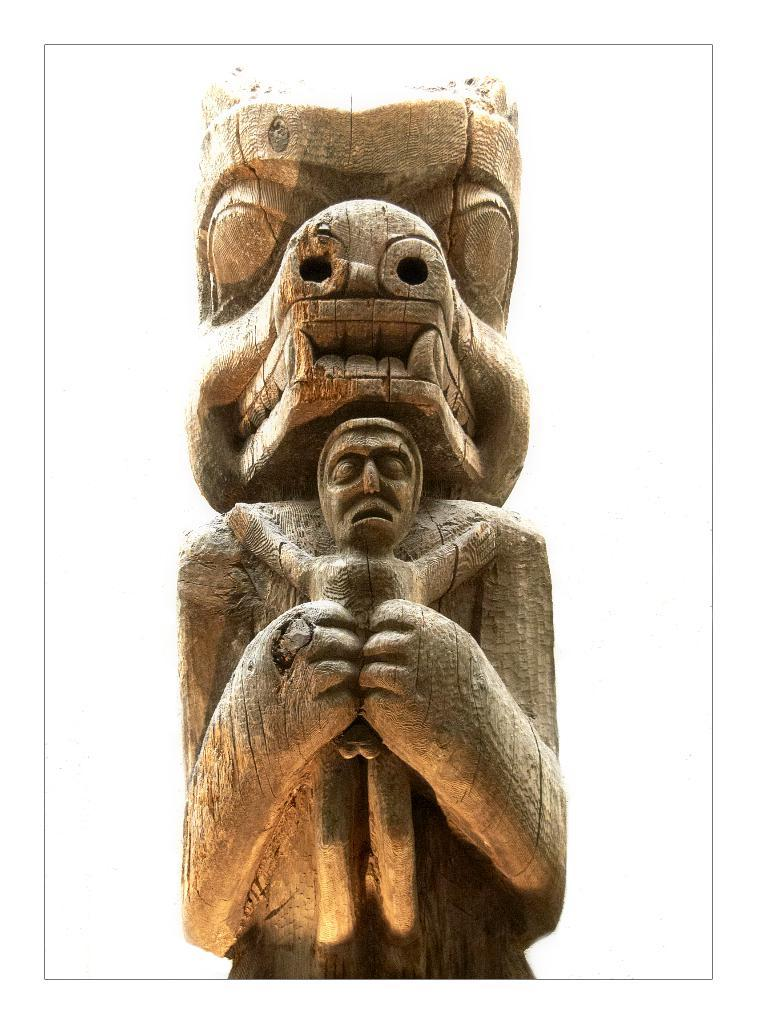What is the main subject of the image? There is a sculpture in the image. What type of treatment is being administered to the sculpture in the image? There is no treatment being administered to the sculpture in the image, as it is a static object. Can you see an argument taking place between the sculpture and another object in the image? There is no argument present in the image, as it only features a sculpture. 